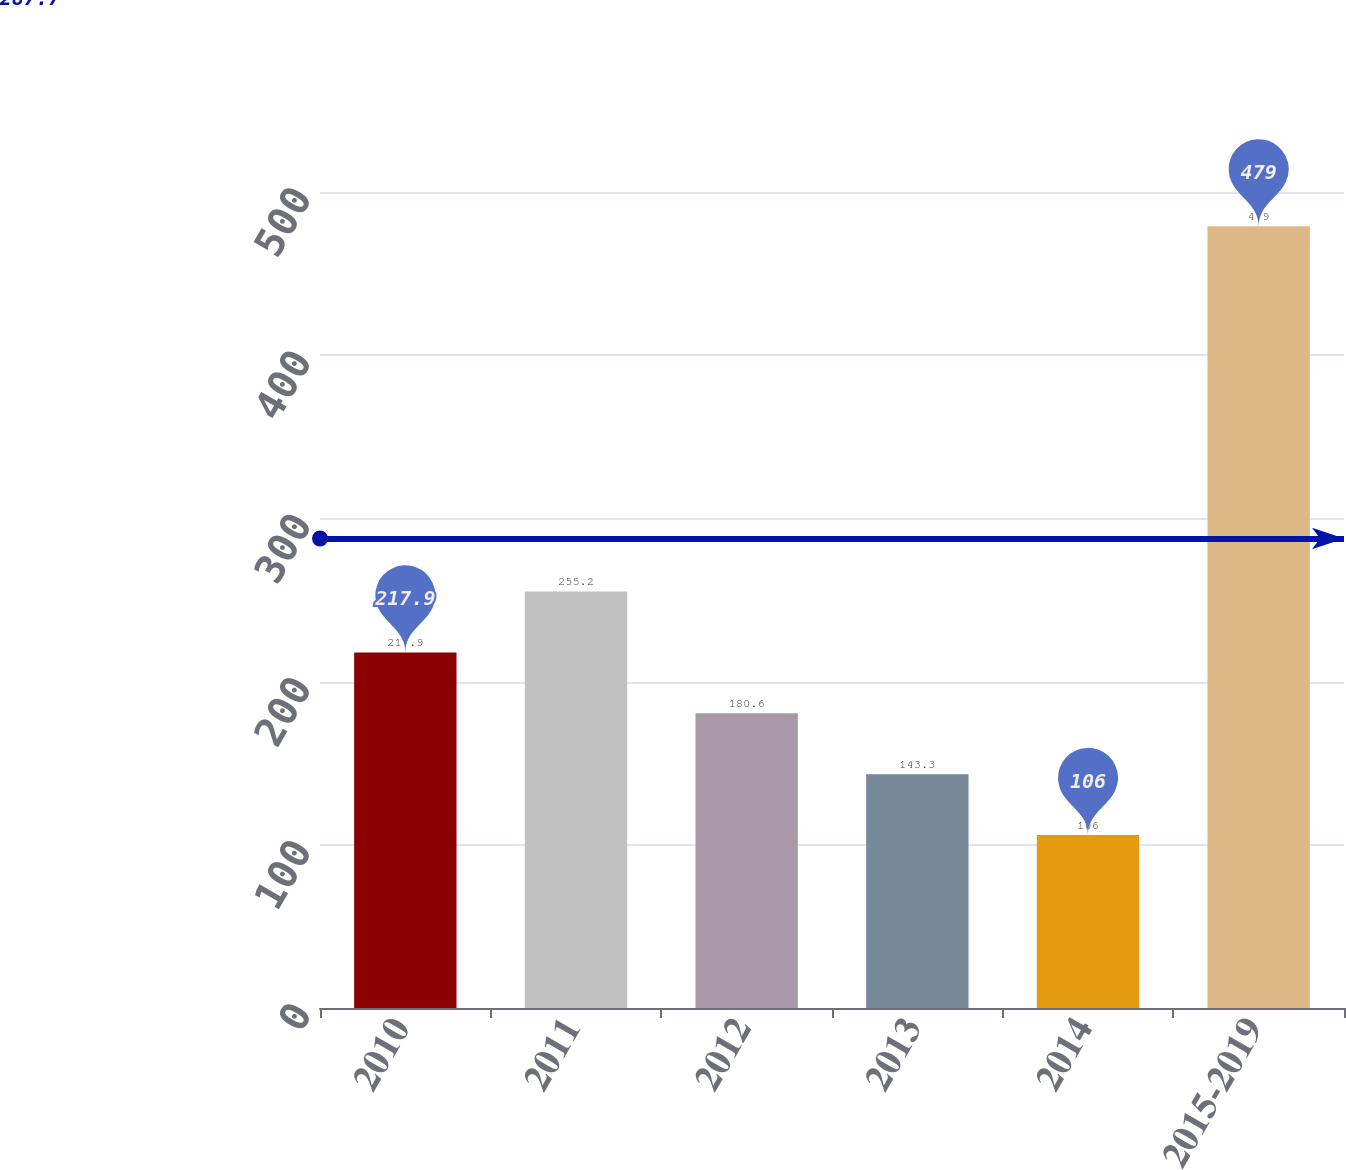<chart> <loc_0><loc_0><loc_500><loc_500><bar_chart><fcel>2010<fcel>2011<fcel>2012<fcel>2013<fcel>2014<fcel>2015-2019<nl><fcel>217.9<fcel>255.2<fcel>180.6<fcel>143.3<fcel>106<fcel>479<nl></chart> 